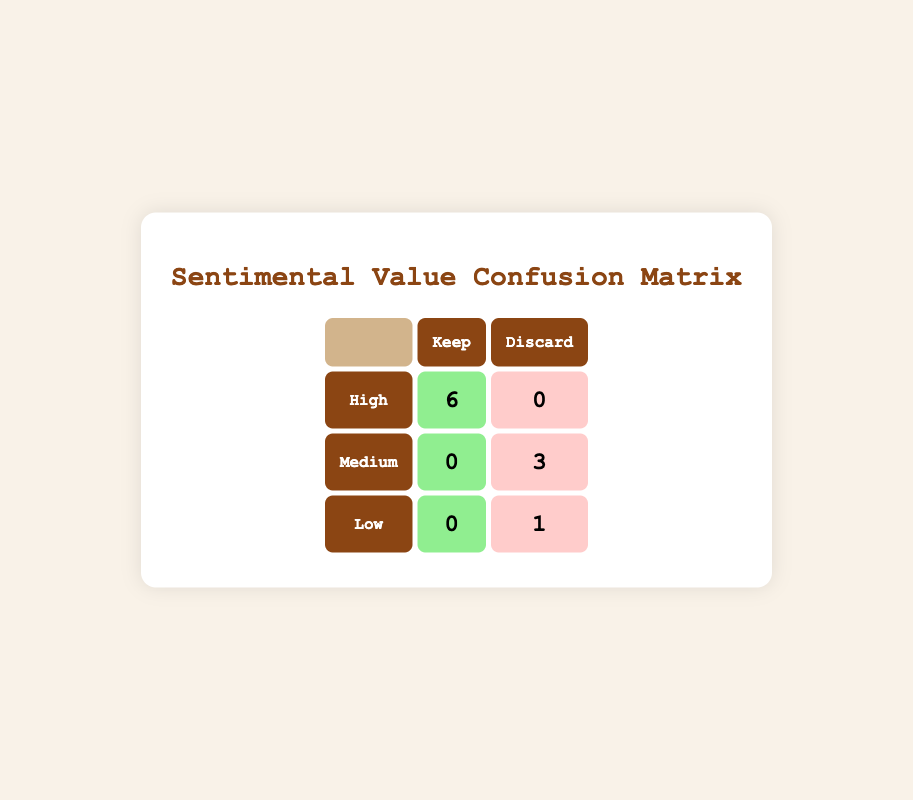What is the total number of items classified as "High" sentimental value? From the table, there are 6 items listed under the "High" row that are marked as "Keep." No items are marked as "Discard" in this category, so the total number of items with high sentimental value is 6.
Answer: 6 How many items were discarded that had "Medium" sentimental value? The table indicates that there are 3 items listed under the "Medium" row classified as "Discard." Therefore, the total number of items with medium sentimental value that were discarded is 3.
Answer: 3 Is there any item classified as "Low" sentimental value that was kept? Looking at the "Low" row, the table shows that there are 0 items marked as "Keep." Hence, the answer is no; there are no low sentimental value items that were kept.
Answer: No What is the ratio of items kept to items discarded in the "High" sentimental value category? In the "High" sentimental value category, there are 6 items kept and 0 items discarded. The ratio of kept to discarded items is 6:0. This means all items with high sentimental value were kept, as there are no items discarded in this category.
Answer: 6:0 How many total items are there in the "Medium" sentimental value category? The table shows that there are 3 items classified as "Discard," and none are kept. So the total number of items with medium sentimental value is 3 (0 kept + 3 discarded = 3).
Answer: 3 What is the total number of items discarded across all sentimental value categories? The table shows there are 3 items from the "Medium" row, and 1 item from the "Low" row that are discarded. Adding these together gives a total of 4 discarded items across all categories.
Answer: 4 Are there any items with "High" sentimental value that were discarded? As per the table, the "High" row shows 0 items are classified as "Discard." Therefore, there are no items with high sentimental value that were discarded.
Answer: No How many items are kept versus discarded overall? The table indicates that 6 items are kept (all in the "High" sentimental value category) and 4 items are discarded (3 in "Medium" and 1 in "Low"). Thus, the total kept versus discarded is 6 kept and 4 discarded.
Answer: 6 kept, 4 discarded 